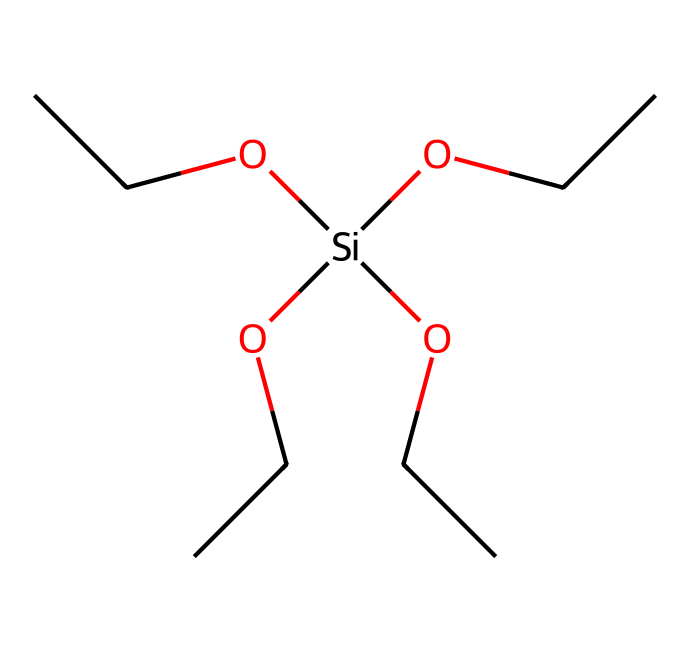what is the name of this compound? The given SMILES representation corresponds to tetraethyl orthosilicate, indicated by the silicate structure and the ethyl groups attached to the silicon atom.
Answer: tetraethyl orthosilicate how many silicon atoms are present in the structure? Analyzing the SMILES, there is only one silicon atom denoted by [Si], which signifies the presence of a single silicon atom in the compound.
Answer: one how many ethyl groups are attached to the silicon atom? The structure includes four ethyl groups represented as OCC, which are attached to the silicon atom, confirming that there are four ethyl groups.
Answer: four what is the overall valency of silicon in this compound? Silicon in tetraethyl orthosilicate adopts a tetravalent state, bonding with four ethyl groups through its four available electron pairs, maintaining its tetravalency.
Answer: four what type of chemical bond connects the silicon to the ethyl groups? The bonds connecting the silicon to the ethyl groups are covalent bonds, as silicon shares electrons with the carbon and hydrogen atoms of the ethyl groups, typical in organosilicon compounds.
Answer: covalent does this compound contain any functional groups? The compound features hydroxy (-OH) groups which are indicative of silicate functionality, integrated into the molecular structure of tetraethyl orthosilicate.
Answer: hydroxy is this compound likely to be soluble in water? Tetraethyl orthosilicate has limited water solubility due to its significant hydrophobic ethyl constituents, which outweigh the hydrophilic characteristics of the hydroxy groups.
Answer: limited 